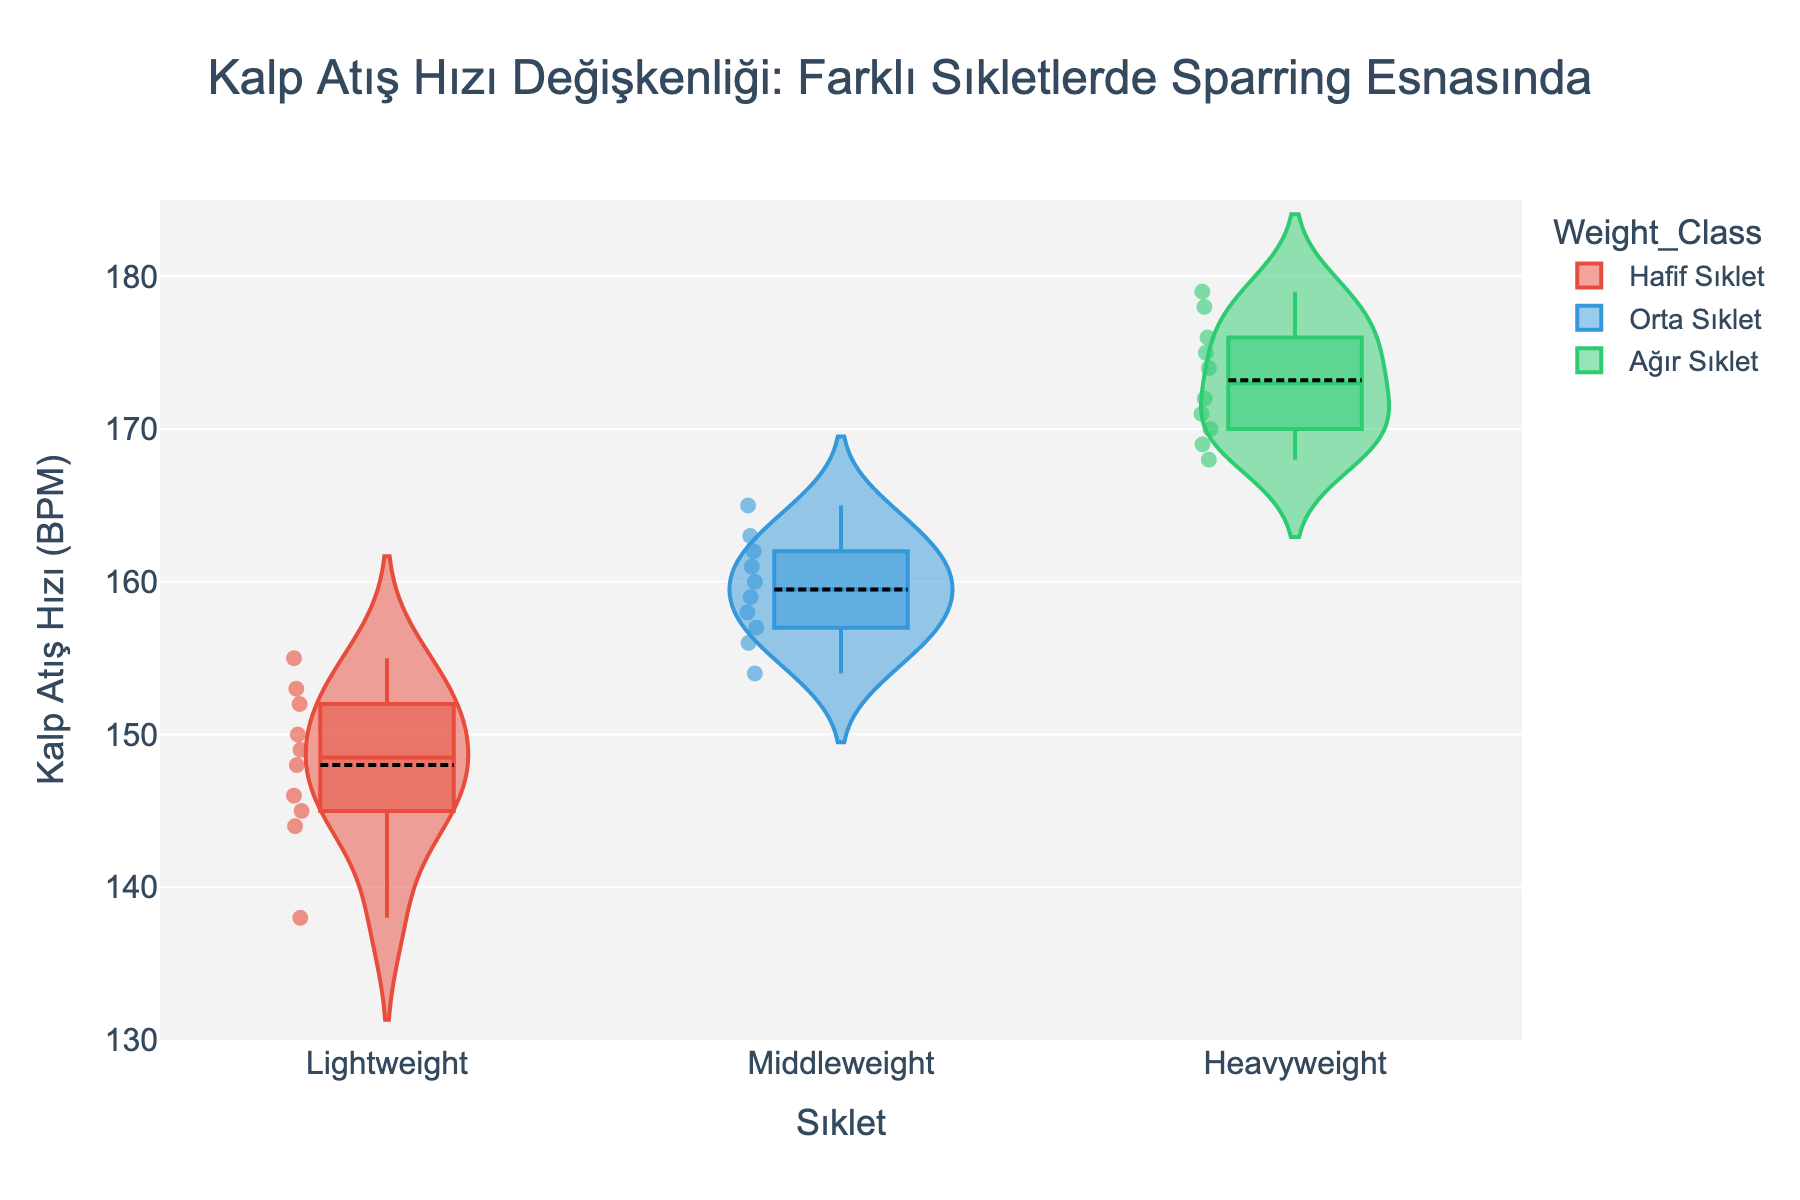Which weight class has the highest median heart rate? To find the highest median heart rate, look at the middle line inside the box on the violin plot for each weight class. The highest median line is in the Heavyweight class.
Answer: Heavyweight What is the range of heart rates in the Lightweight class? Examine the bottom and top extremes of the violin plot for Lightweight. The lowest heart rate is 138 BPM, and the highest heart rate is 155 BPM. The range is 155 - 138
Answer: 17 BPM Which weight class shows the most variability in heart rate? Variability can be inferred from the spread of the violin. The Heavyweight class has the widest spread, showing the most variability.
Answer: Heavyweight How many data points are there in the Middleweight class? Count the number of jittered points within the Middleweight plot. Each point represents a data point. There are 10 points.
Answer: 10 What does the title of the plot indicate? The title of the plot is "Kalp Atış Hızı Değişkenliği: Farklı Sıkletlerde Sparring Esnasında," which translates to "Heart Rate Variability: During Sparring in Different Weight Classes."
Answer: Heart Rate Variability: During Sparring in Different Weight Classes In which weight class do the heart rates tend to cluster around the mean more tightly? To determine clustering, observe how close the points are around the mean line (white line inside the box). The Lightweight class points are more concentrated around the mean.
Answer: Lightweight Which weight class has the lowest minimum heart rate? Compare the lowest points in each violin plot. The lowest point is in the Lightweight class with a value of 138 BPM.
Answer: Lightweight What is the mean heart rate in the Middleweight class? The mean is the white line inside the box. In the Middleweight class, the mean heart rate is around 160 BPM.
Answer: 160 BPM Which weight class has the broadest interquartile range (IQR)? The IQR is the range between the bottom and top of the box. The Heavyweight class has the broadest box width, showing the widest IQR.
Answer: Heavyweight 